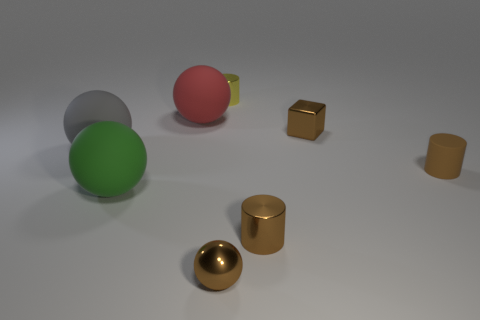Subtract all cyan spheres. How many brown cylinders are left? 2 Subtract all brown cylinders. How many cylinders are left? 1 Subtract 1 balls. How many balls are left? 3 Subtract all blue balls. Subtract all blue cubes. How many balls are left? 4 Add 1 red rubber balls. How many objects exist? 9 Subtract all blocks. How many objects are left? 7 Subtract 1 yellow cylinders. How many objects are left? 7 Subtract all big green balls. Subtract all large yellow objects. How many objects are left? 7 Add 5 cylinders. How many cylinders are left? 8 Add 8 tiny balls. How many tiny balls exist? 9 